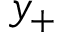Convert formula to latex. <formula><loc_0><loc_0><loc_500><loc_500>y _ { + }</formula> 